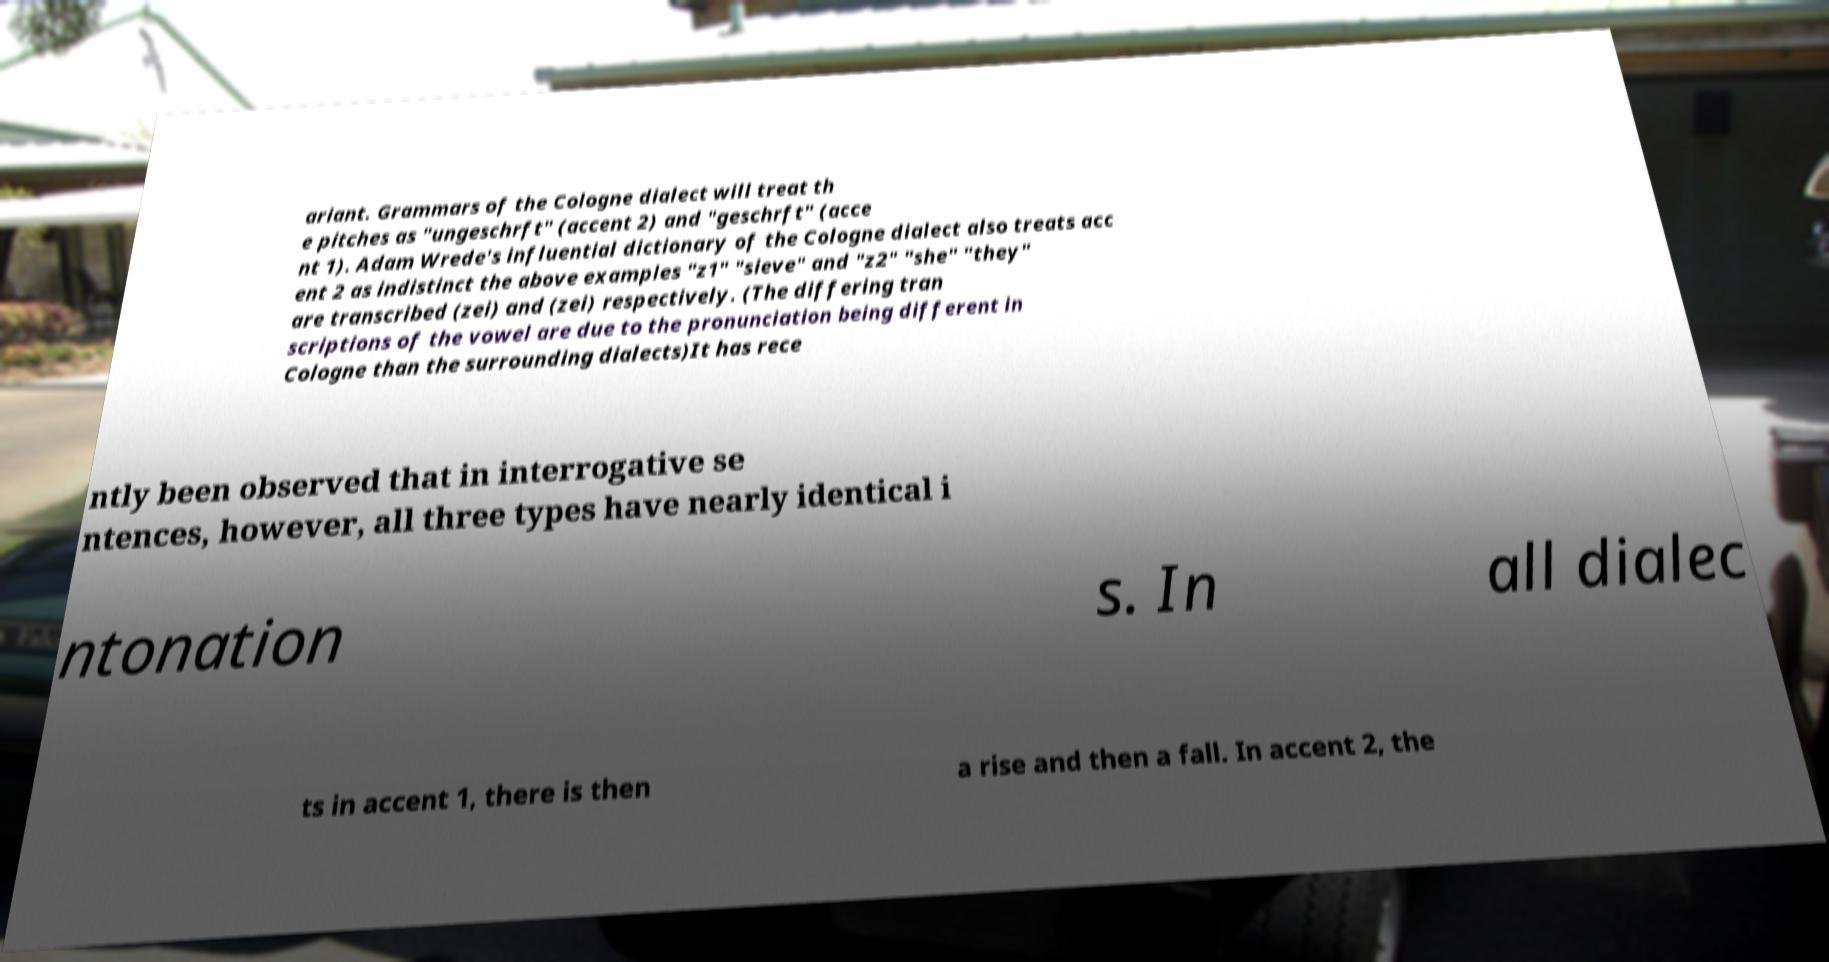There's text embedded in this image that I need extracted. Can you transcribe it verbatim? ariant. Grammars of the Cologne dialect will treat th e pitches as "ungeschrft" (accent 2) and "geschrft" (acce nt 1). Adam Wrede's influential dictionary of the Cologne dialect also treats acc ent 2 as indistinct the above examples "z1" "sieve" and "z2" "she" "they" are transcribed (zei) and (zei) respectively. (The differing tran scriptions of the vowel are due to the pronunciation being different in Cologne than the surrounding dialects)It has rece ntly been observed that in interrogative se ntences, however, all three types have nearly identical i ntonation s. In all dialec ts in accent 1, there is then a rise and then a fall. In accent 2, the 